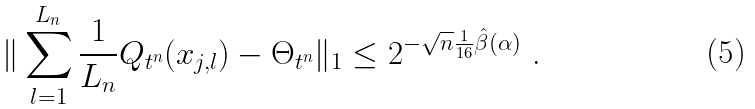Convert formula to latex. <formula><loc_0><loc_0><loc_500><loc_500>\| \sum _ { l = 1 } ^ { L _ { n } } \frac { 1 } { L _ { n } } Q _ { t ^ { n } } ( x _ { j , l } ) - \Theta _ { t ^ { n } } \| _ { 1 } \leq 2 ^ { - \sqrt { n } \frac { 1 } { 1 6 } \hat { \beta } ( \alpha ) } \text { .}</formula> 